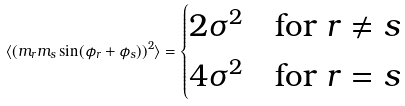<formula> <loc_0><loc_0><loc_500><loc_500>\langle ( m _ { r } m _ { s } \sin ( \phi _ { r } + \phi _ { s } ) ) ^ { 2 } \rangle = \begin{cases} 2 \sigma ^ { 2 } & \text {for $r\neq s$} \\ 4 \sigma ^ { 2 } & \text {for $r= s$} \\ \end{cases}</formula> 